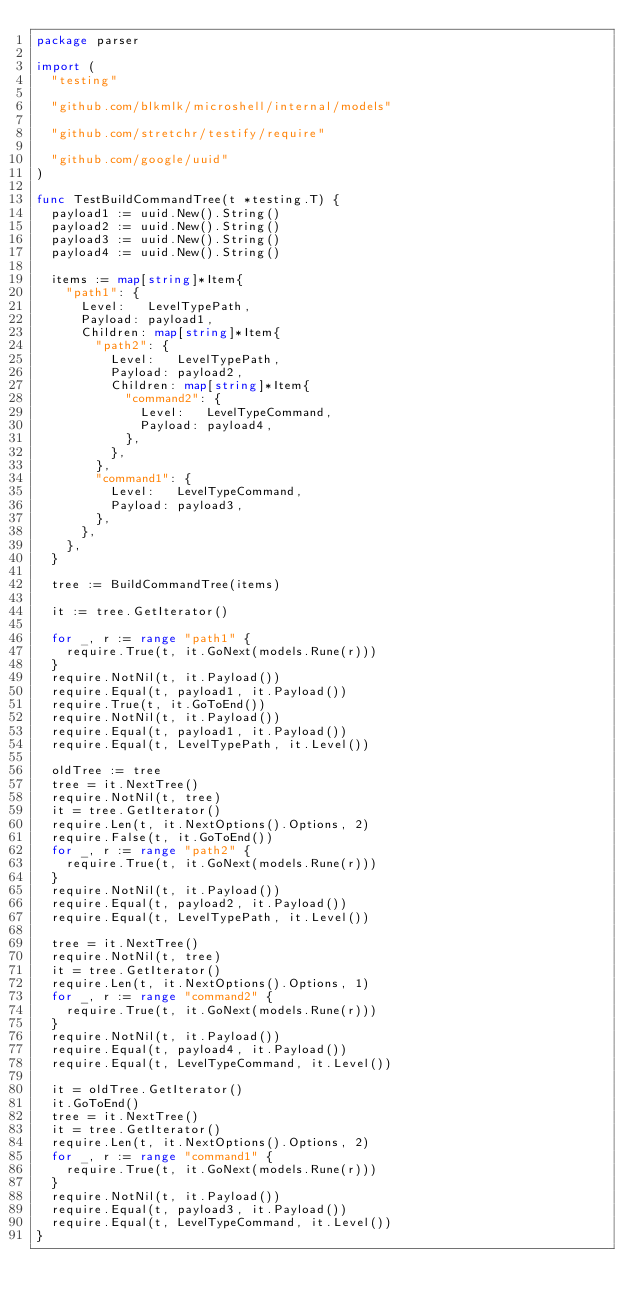Convert code to text. <code><loc_0><loc_0><loc_500><loc_500><_Go_>package parser

import (
	"testing"

	"github.com/blkmlk/microshell/internal/models"

	"github.com/stretchr/testify/require"

	"github.com/google/uuid"
)

func TestBuildCommandTree(t *testing.T) {
	payload1 := uuid.New().String()
	payload2 := uuid.New().String()
	payload3 := uuid.New().String()
	payload4 := uuid.New().String()

	items := map[string]*Item{
		"path1": {
			Level:   LevelTypePath,
			Payload: payload1,
			Children: map[string]*Item{
				"path2": {
					Level:   LevelTypePath,
					Payload: payload2,
					Children: map[string]*Item{
						"command2": {
							Level:   LevelTypeCommand,
							Payload: payload4,
						},
					},
				},
				"command1": {
					Level:   LevelTypeCommand,
					Payload: payload3,
				},
			},
		},
	}

	tree := BuildCommandTree(items)

	it := tree.GetIterator()

	for _, r := range "path1" {
		require.True(t, it.GoNext(models.Rune(r)))
	}
	require.NotNil(t, it.Payload())
	require.Equal(t, payload1, it.Payload())
	require.True(t, it.GoToEnd())
	require.NotNil(t, it.Payload())
	require.Equal(t, payload1, it.Payload())
	require.Equal(t, LevelTypePath, it.Level())

	oldTree := tree
	tree = it.NextTree()
	require.NotNil(t, tree)
	it = tree.GetIterator()
	require.Len(t, it.NextOptions().Options, 2)
	require.False(t, it.GoToEnd())
	for _, r := range "path2" {
		require.True(t, it.GoNext(models.Rune(r)))
	}
	require.NotNil(t, it.Payload())
	require.Equal(t, payload2, it.Payload())
	require.Equal(t, LevelTypePath, it.Level())

	tree = it.NextTree()
	require.NotNil(t, tree)
	it = tree.GetIterator()
	require.Len(t, it.NextOptions().Options, 1)
	for _, r := range "command2" {
		require.True(t, it.GoNext(models.Rune(r)))
	}
	require.NotNil(t, it.Payload())
	require.Equal(t, payload4, it.Payload())
	require.Equal(t, LevelTypeCommand, it.Level())

	it = oldTree.GetIterator()
	it.GoToEnd()
	tree = it.NextTree()
	it = tree.GetIterator()
	require.Len(t, it.NextOptions().Options, 2)
	for _, r := range "command1" {
		require.True(t, it.GoNext(models.Rune(r)))
	}
	require.NotNil(t, it.Payload())
	require.Equal(t, payload3, it.Payload())
	require.Equal(t, LevelTypeCommand, it.Level())
}
</code> 